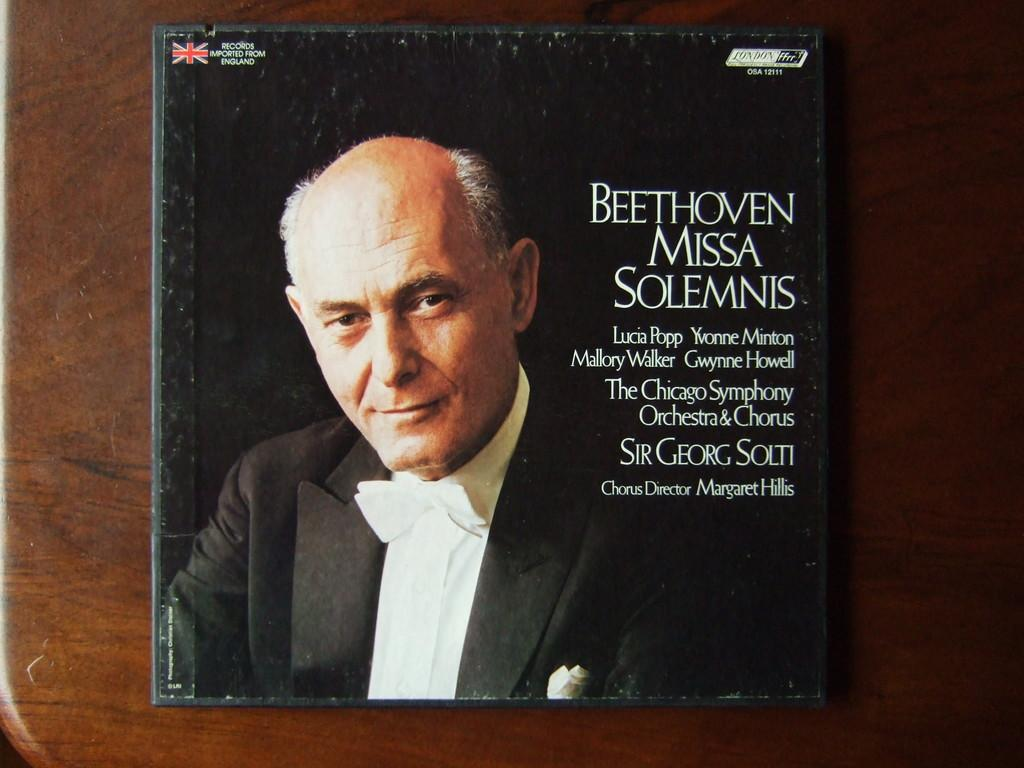Provide a one-sentence caption for the provided image. cd of Beethoven Missa Solemnis with a picture of older man in a tuxedo on it. 